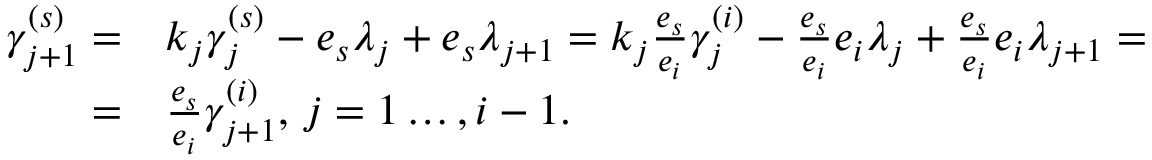<formula> <loc_0><loc_0><loc_500><loc_500>\begin{array} { r l } { \gamma _ { j + 1 } ^ { ( s ) } = } & { k _ { j } \gamma _ { j } ^ { ( s ) } - e _ { s } \lambda _ { j } + e _ { s } \lambda _ { j + 1 } = k _ { j } \frac { e _ { s } } { e _ { i } } \gamma _ { j } ^ { ( i ) } - \frac { e _ { s } } { e _ { i } } e _ { i } \lambda _ { j } + \frac { e _ { s } } { e _ { i } } e _ { i } \lambda _ { j + 1 } = } \\ { = } & { \frac { e _ { s } } { e _ { i } } \gamma _ { j + 1 } ^ { ( i ) } , \, j = 1 \dots , i - 1 . } \end{array}</formula> 